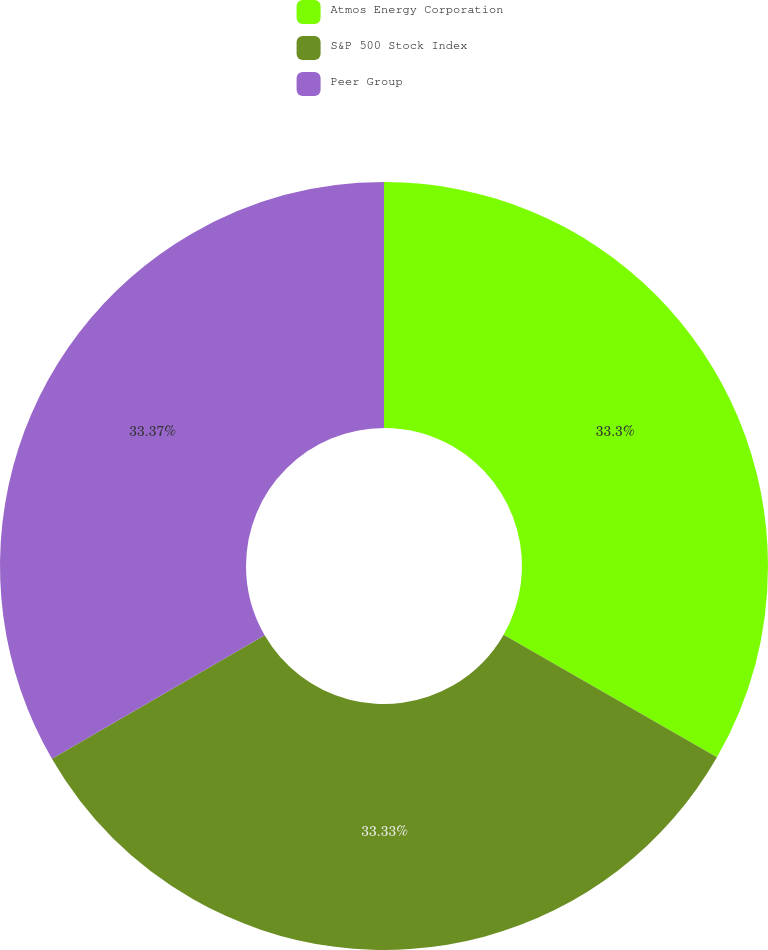<chart> <loc_0><loc_0><loc_500><loc_500><pie_chart><fcel>Atmos Energy Corporation<fcel>S&P 500 Stock Index<fcel>Peer Group<nl><fcel>33.3%<fcel>33.33%<fcel>33.37%<nl></chart> 